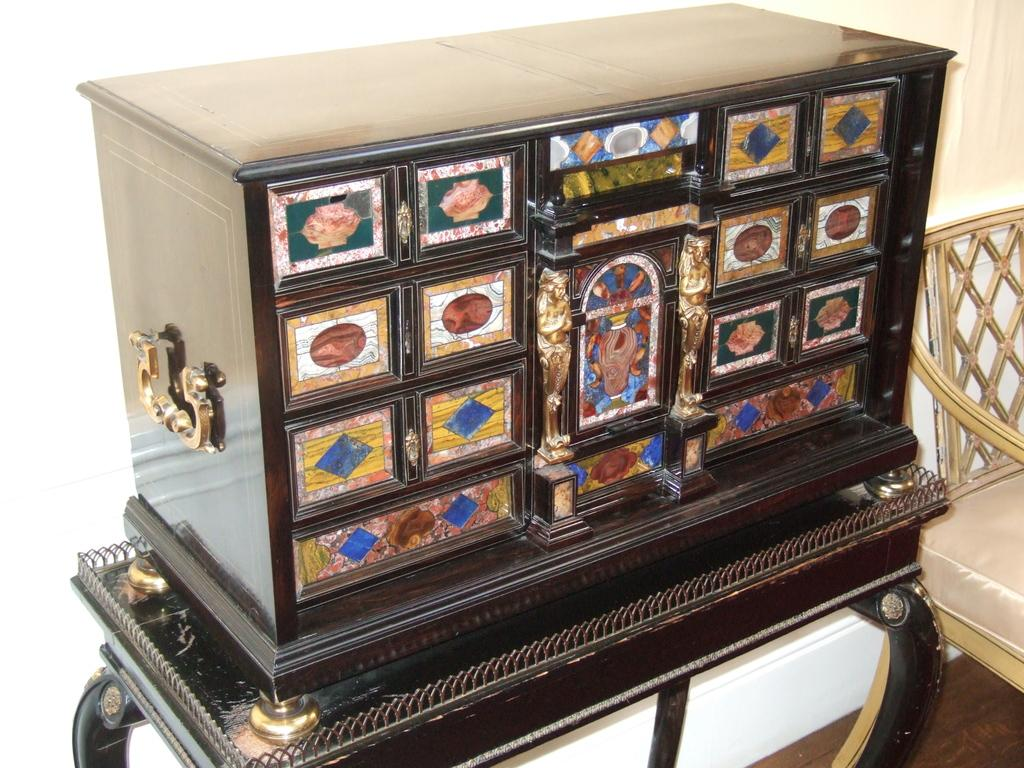What is on the box that is visible in the image? There is a box with images on it in the image. Where is the box located in the image? The box is placed on a table in the image. What is near the table in the image? There is a chair beside the table in the image. Can you see a monkey performing a shocking trick on the chair in the image? No, there is no monkey or any shocking trick involving a monkey in the image. 